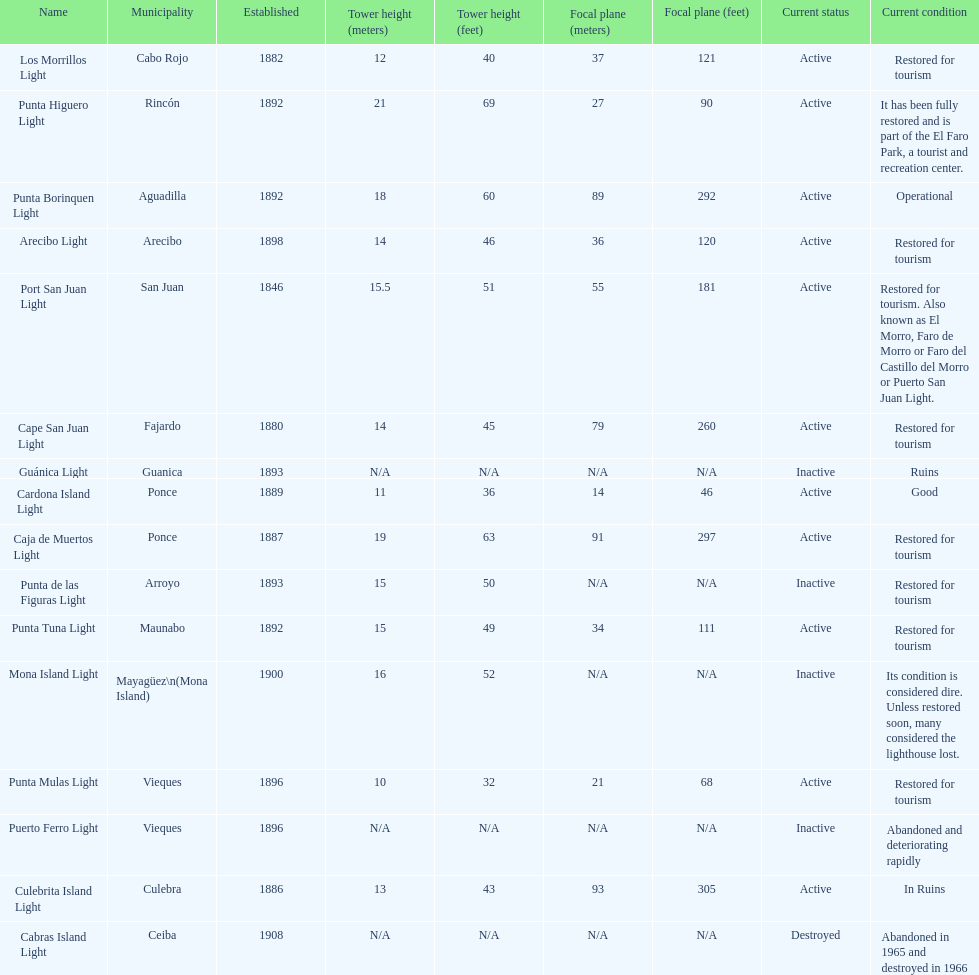How many towers are at least 18 meters tall? 3. 